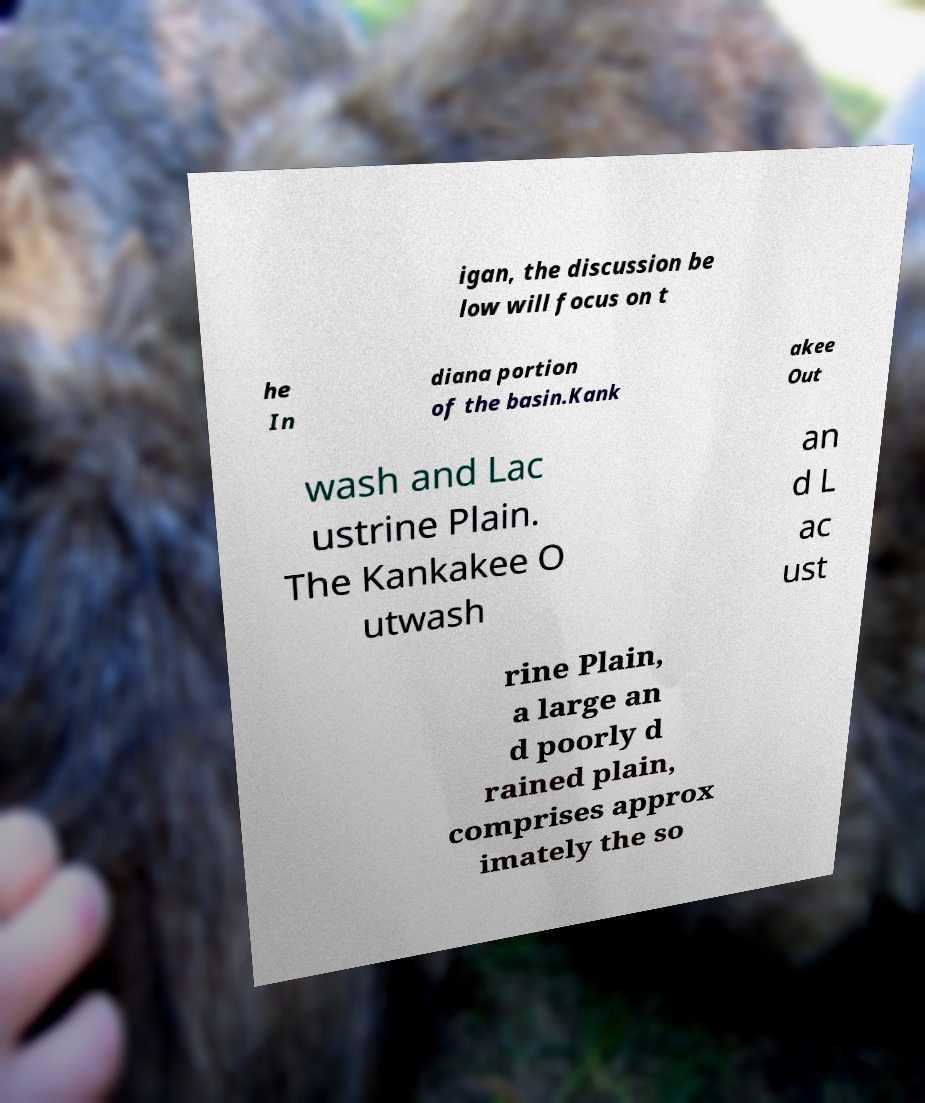There's text embedded in this image that I need extracted. Can you transcribe it verbatim? igan, the discussion be low will focus on t he In diana portion of the basin.Kank akee Out wash and Lac ustrine Plain. The Kankakee O utwash an d L ac ust rine Plain, a large an d poorly d rained plain, comprises approx imately the so 